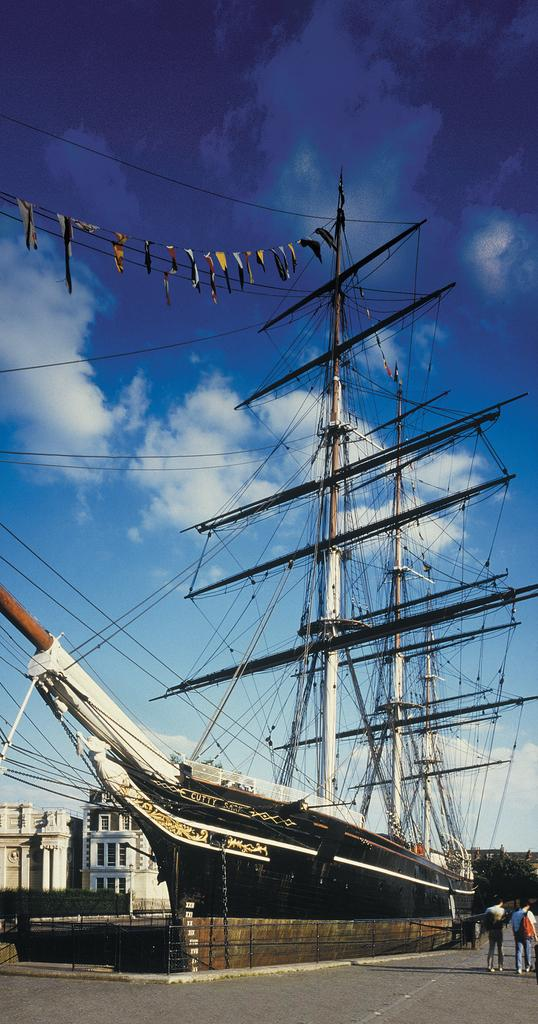What is the main subject of the image? The main subject of the image is a ship on the ground. What else can be seen in the image besides the ship? There are wires visible in the image, as well as two persons standing and buildings in the background. What is the condition of the sky in the image? The sky is cloudy in the image. Can you see a train passing by the ship in the image? There is no train present in the image; it features a ship on the ground, wires, two persons standing, buildings in the background, and a cloudy sky. Is there a crown visible on the head of one of the persons in the image? There is no crown present on the head of any person in the image. 